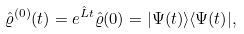Convert formula to latex. <formula><loc_0><loc_0><loc_500><loc_500>\hat { \varrho } ^ { ( 0 ) } ( t ) = e ^ { \hat { L } t } \hat { \varrho } ( 0 ) = | \Psi ( t ) \rangle \langle \Psi ( t ) | ,</formula> 